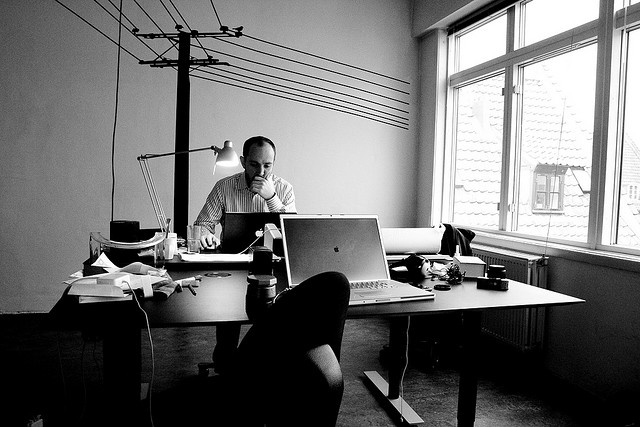Describe the objects in this image and their specific colors. I can see chair in black, gray, darkgray, and lightgray tones, laptop in black, gray, darkgray, and lightgray tones, people in black, gray, darkgray, and lightgray tones, chair in black, darkgray, gray, and lightgray tones, and laptop in black, lightgray, darkgray, and gray tones in this image. 